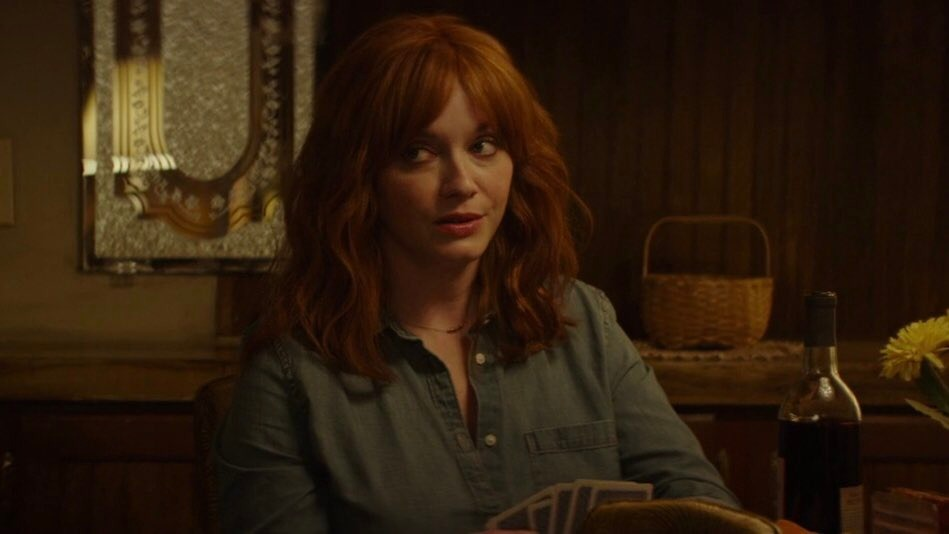Create a short dialogue that might fit this scene. Human: "I can't believe it's been so long since we last talked like this."
Christina: "Yes, time flies. But some things never change, do they?"
Human: "That's true. We should make a habit of this, not let years go by."
Christina: "Absolutely. Maybe next time, no big revelations though? Just good wine and better company."  Can we delve into what might be the significance of the yellow flowers? The yellow flowers could symbolize many things. Traditionally, yellow flowers often represent friendship and joy. In this context, they might have been a gift from a close friend, symbolizing the warmth and positivity they bring into her life. Alternatively, the flowers might serve as a personal reminder of happier times, blooming as a constant presence of hope and cheer amidst the more serious atmosphere of the scene.  What if the scene were part of a mystery film? How would it fit into the storyline? If this were a scene from a mystery film, it could be a crucial moment where the protagonist, Christina, begins to piece together clues that unravel the larger plot. The serene setting of the dimly lit room contrasts with the growing tension as she reflects on a cryptic message or an unexpected revelation shared over the wine. The slightly puzzled look hints at her realization of a connection she had previously missed, setting the stage for the next step in her investigation. The vase of yellow flowers might even be a subtle hint left by an ally or a nemesis, containing a hidden message that she is about to decode. 